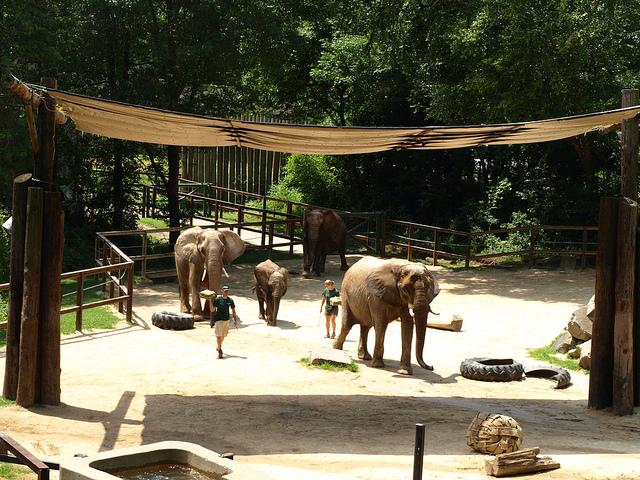Is this their natural habitat?
Short answer required. No. How many elephants in the image?
Concise answer only. 4. Does the canopy top give off shade?
Keep it brief. Yes. 